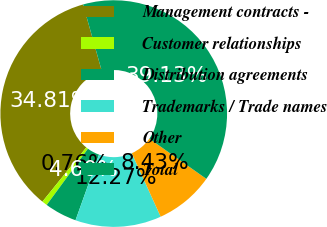Convert chart. <chart><loc_0><loc_0><loc_500><loc_500><pie_chart><fcel>Management contracts -<fcel>Customer relationships<fcel>Distribution agreements<fcel>Trademarks / Trade names<fcel>Other<fcel>Total<nl><fcel>34.81%<fcel>0.76%<fcel>4.6%<fcel>12.27%<fcel>8.43%<fcel>39.13%<nl></chart> 